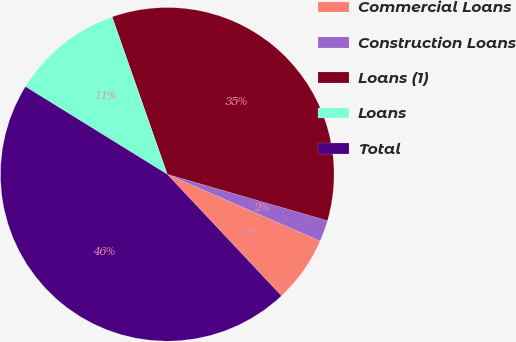<chart> <loc_0><loc_0><loc_500><loc_500><pie_chart><fcel>Commercial Loans<fcel>Construction Loans<fcel>Loans (1)<fcel>Loans<fcel>Total<nl><fcel>6.44%<fcel>2.07%<fcel>34.85%<fcel>10.82%<fcel>45.82%<nl></chart> 